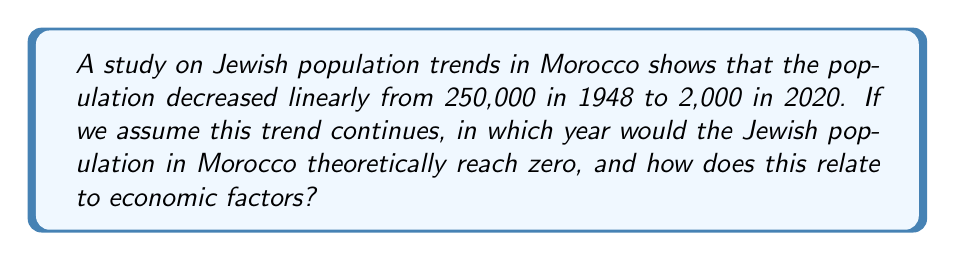Teach me how to tackle this problem. To solve this problem, we need to use the linear equation model:

1) Let's define our variables:
   $y$ = Jewish population
   $x$ = years since 1948
   
2) We have two points: (0, 250000) and (72, 2000)

3) We can use the point-slope form of a line:
   $y - y_1 = m(x - x_1)$

4) Calculate the slope:
   $m = \frac{y_2 - y_1}{x_2 - x_1} = \frac{2000 - 250000}{72 - 0} = -3444.44$

5) Our equation becomes:
   $y - 250000 = -3444.44(x - 0)$
   $y = -3444.44x + 250000$

6) To find when $y = 0$:
   $0 = -3444.44x + 250000$
   $3444.44x = 250000$
   $x = 72.58$ years after 1948

7) 72.58 years after 1948 is 2020.58, or early 2021.

This linear decrease likely correlates with economic factors such as:
- Increased economic opportunities elsewhere
- Economic instability in Morocco
- Changes in trade policies affecting Jewish-owned businesses

However, it's important to note that population trends are influenced by many factors beyond economics, including political and social considerations.
Answer: Early 2021 